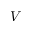<formula> <loc_0><loc_0><loc_500><loc_500>V</formula> 